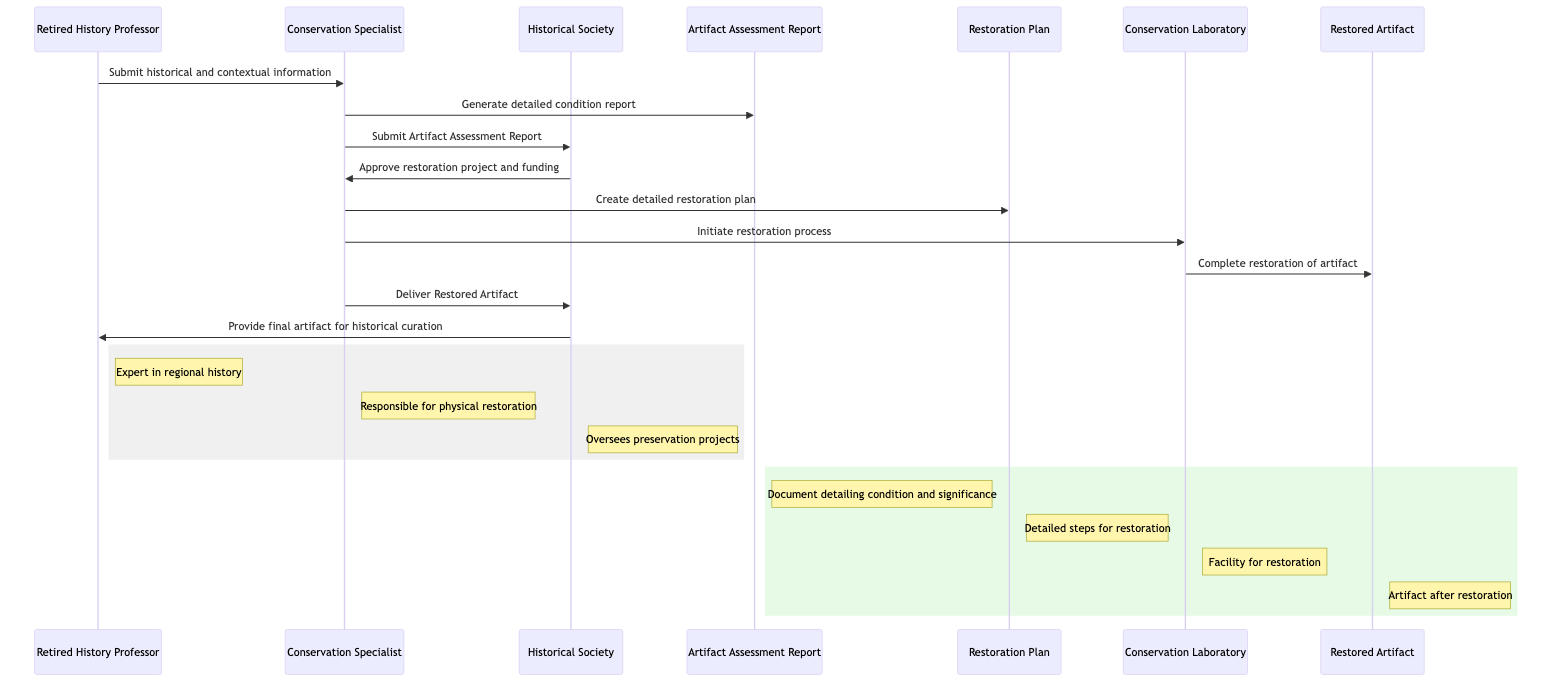What roles are represented in the diagram? The diagram includes three roles: "Retired History Professor," "Conservation Specialist," and "Historical Society." These are depicted as actors in the sequence diagram and represent different stakeholders in the restoration process.
Answer: Retired History Professor, Conservation Specialist, Historical Society What document is created by the Conservation Specialist? The Conservation Specialist generates the "Artifact Assessment Report," which is shown as a direct output from that actor in the sequence. This document details the condition and historical significance of the artifact.
Answer: Artifact Assessment Report How many messages are sent in total? By counting the arrows in the sequence diagram, we find that there are a total of nine messages exchanged between the actors. Each arrow corresponds to a message, indicating the flow of information and actions in the restoration process.
Answer: Nine Who approves the restoration project and funding? The "Historical Society" is responsible for approving the restoration project and funding, as indicated by a message sent from the Historical Society back to the Conservation Specialist.
Answer: Historical Society What is the final output of the restoration process? The final output of the restoration process is the "Restored Artifact," which is received by the Conservation Specialist after completing the restoration in the Conservation Laboratory. This is depicted at the end of the sequence flow.
Answer: Restored Artifact Which participant receives the final artifact for curation? The "Retired History Professor" receives the final artifact for historical curation as depicted in the last message from the Historical Society. This indicates the role of the Retired History Professor in overseeing the historical aspects of the artifacts.
Answer: Retired History Professor Describe the relationship between the Conservation Specialist and the Conservation Laboratory. The "Conservation Specialist" initiates the restoration process by sending a message to the "Conservation Laboratory." This relationship demonstrates that the conservation specialist is responsible for initiating actions within the laboratory to restore artifacts.
Answer: Initiates restoration process What type of report is generated after the historical information is submitted? The "Artifact Assessment Report" is generated as a detailed condition report after the historical information is provided by the Retired History Professor to the Conservation Specialist. This shows the significance of historical context in the assessment process.
Answer: Detailed condition report What happens after the completion of the restoration process? After the restoration process is completed, the Conservation Laboratory sends the "Restored Artifact" to the Conservation Specialist, indicating that the restoration stages have successfully transitioned to delivering the restored item.
Answer: Deliver Restored Artifact 